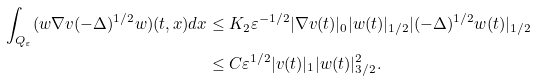<formula> <loc_0><loc_0><loc_500><loc_500>\int _ { Q _ { \varepsilon } } ( w \nabla v ( - \Delta ) ^ { 1 / 2 } w ) ( t , x ) d x & \leq K _ { 2 } \varepsilon ^ { - 1 / 2 } | \nabla v ( t ) | _ { 0 } | w ( t ) | _ { 1 / 2 } | ( - \Delta ) ^ { 1 / 2 } w ( t ) | _ { 1 / 2 } \\ & \leq C \varepsilon ^ { 1 / 2 } | v ( t ) | _ { 1 } | w ( t ) | _ { 3 / 2 } ^ { 2 } .</formula> 